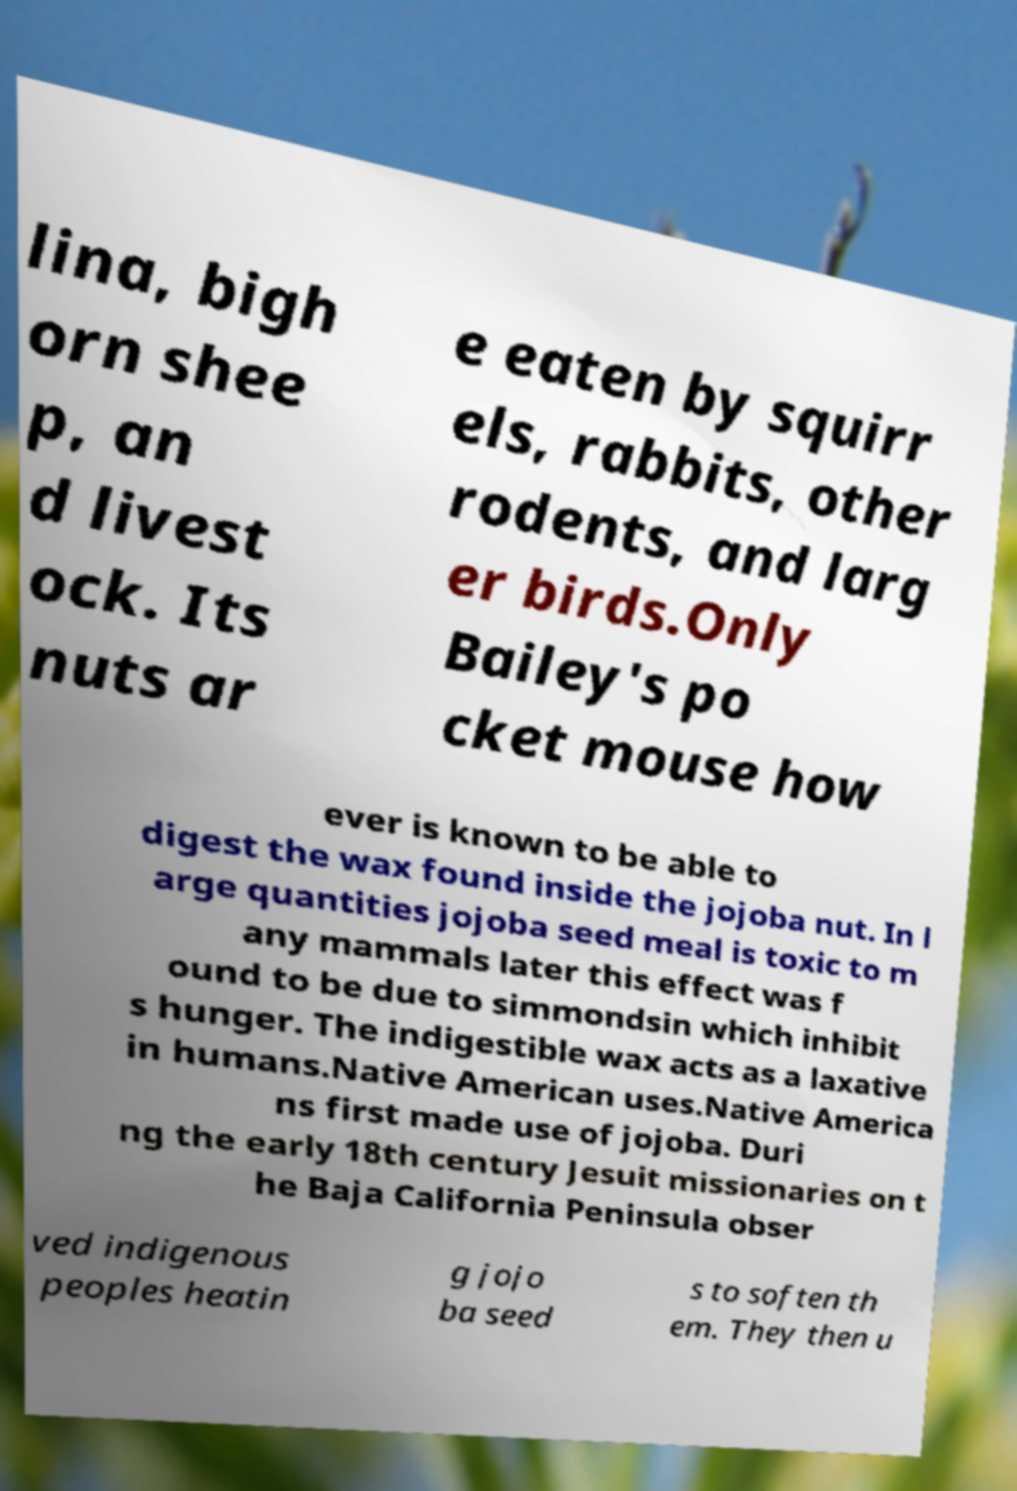There's text embedded in this image that I need extracted. Can you transcribe it verbatim? lina, bigh orn shee p, an d livest ock. Its nuts ar e eaten by squirr els, rabbits, other rodents, and larg er birds.Only Bailey's po cket mouse how ever is known to be able to digest the wax found inside the jojoba nut. In l arge quantities jojoba seed meal is toxic to m any mammals later this effect was f ound to be due to simmondsin which inhibit s hunger. The indigestible wax acts as a laxative in humans.Native American uses.Native America ns first made use of jojoba. Duri ng the early 18th century Jesuit missionaries on t he Baja California Peninsula obser ved indigenous peoples heatin g jojo ba seed s to soften th em. They then u 